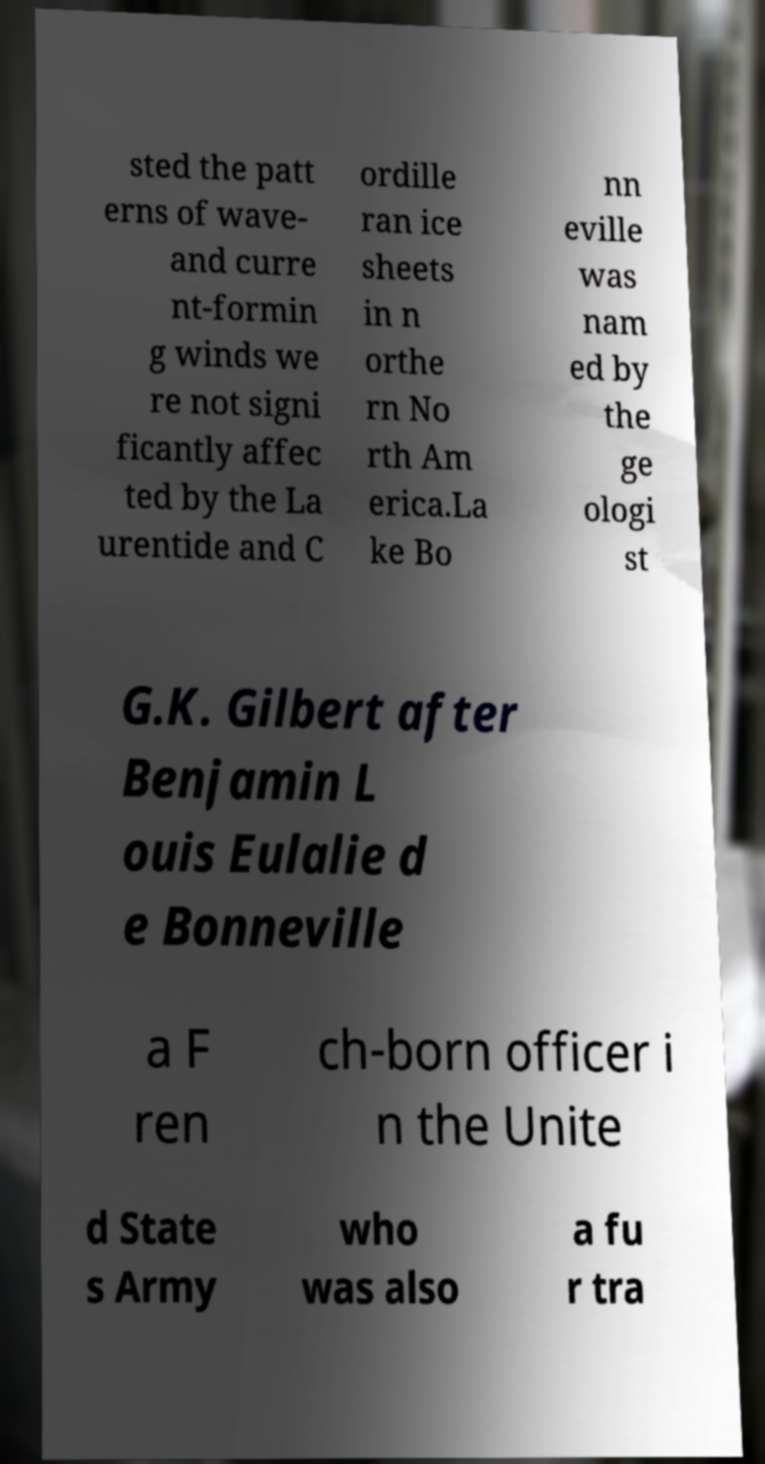Please identify and transcribe the text found in this image. sted the patt erns of wave- and curre nt-formin g winds we re not signi ficantly affec ted by the La urentide and C ordille ran ice sheets in n orthe rn No rth Am erica.La ke Bo nn eville was nam ed by the ge ologi st G.K. Gilbert after Benjamin L ouis Eulalie d e Bonneville a F ren ch-born officer i n the Unite d State s Army who was also a fu r tra 